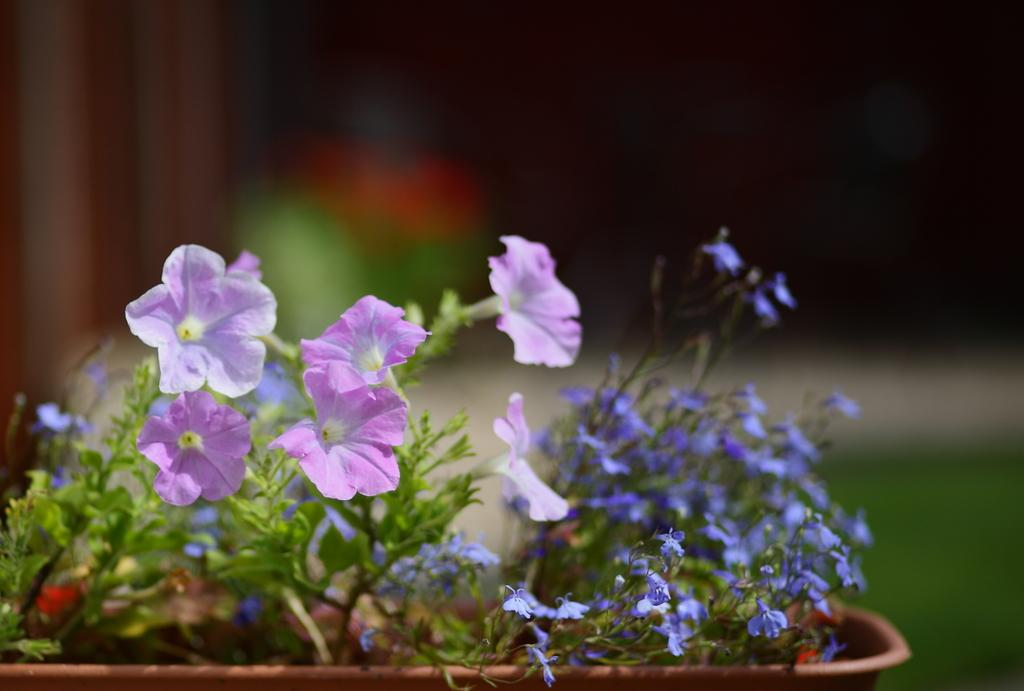What is located in the foreground of the picture? There is a flower pot in the foreground of the picture. What can be found inside the flower pot? The flower pot contains plants and flowers. How would you describe the background of the image? The background of the image is blurred. Are there any branches visible in the garden in the image? There is no garden present in the image, only a flower pot with plants and flowers in the foreground. 